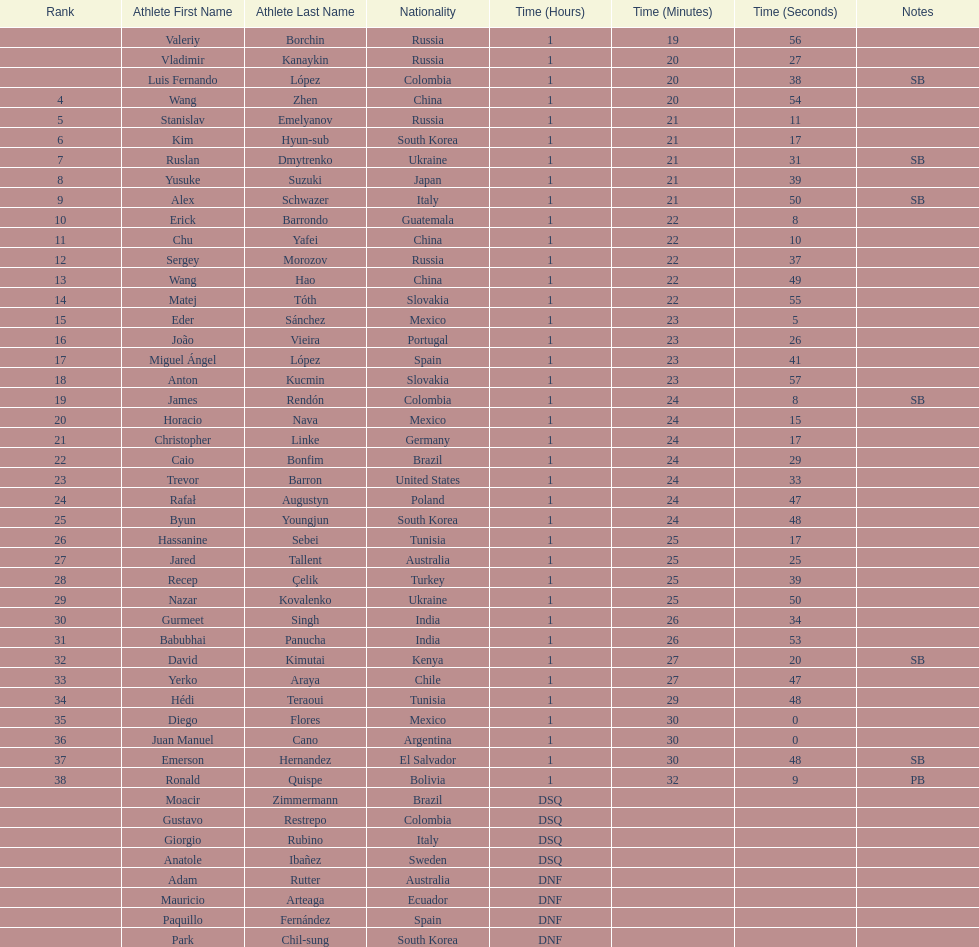Which athlete had the fastest time for the 20km? Valeriy Borchin. Can you parse all the data within this table? {'header': ['Rank', 'Athlete First Name', 'Athlete Last Name', 'Nationality', 'Time (Hours)', 'Time (Minutes)', 'Time (Seconds)', 'Notes'], 'rows': [['', 'Valeriy', 'Borchin', 'Russia', '1', '19', '56', ''], ['', 'Vladimir', 'Kanaykin', 'Russia', '1', '20', '27', ''], ['', 'Luis Fernando', 'López', 'Colombia', '1', '20', '38', 'SB'], ['4', 'Wang', 'Zhen', 'China', '1', '20', '54', ''], ['5', 'Stanislav', 'Emelyanov', 'Russia', '1', '21', '11', ''], ['6', 'Kim', 'Hyun-sub', 'South Korea', '1', '21', '17', ''], ['7', 'Ruslan', 'Dmytrenko', 'Ukraine', '1', '21', '31', 'SB'], ['8', 'Yusuke', 'Suzuki', 'Japan', '1', '21', '39', ''], ['9', 'Alex', 'Schwazer', 'Italy', '1', '21', '50', 'SB'], ['10', 'Erick', 'Barrondo', 'Guatemala', '1', '22', '8', ''], ['11', 'Chu', 'Yafei', 'China', '1', '22', '10', ''], ['12', 'Sergey', 'Morozov', 'Russia', '1', '22', '37', ''], ['13', 'Wang', 'Hao', 'China', '1', '22', '49', ''], ['14', 'Matej', 'Tóth', 'Slovakia', '1', '22', '55', ''], ['15', 'Eder', 'Sánchez', 'Mexico', '1', '23', '5', ''], ['16', 'João', 'Vieira', 'Portugal', '1', '23', '26', ''], ['17', 'Miguel Ángel', 'López', 'Spain', '1', '23', '41', ''], ['18', 'Anton', 'Kucmin', 'Slovakia', '1', '23', '57', ''], ['19', 'James', 'Rendón', 'Colombia', '1', '24', '8', 'SB'], ['20', 'Horacio', 'Nava', 'Mexico', '1', '24', '15', ''], ['21', 'Christopher', 'Linke', 'Germany', '1', '24', '17', ''], ['22', 'Caio', 'Bonfim', 'Brazil', '1', '24', '29', ''], ['23', 'Trevor', 'Barron', 'United States', '1', '24', '33', ''], ['24', 'Rafał', 'Augustyn', 'Poland', '1', '24', '47', ''], ['25', 'Byun', 'Youngjun', 'South Korea', '1', '24', '48', ''], ['26', 'Hassanine', 'Sebei', 'Tunisia', '1', '25', '17', ''], ['27', 'Jared', 'Tallent', 'Australia', '1', '25', '25', ''], ['28', 'Recep', 'Çelik', 'Turkey', '1', '25', '39', ''], ['29', 'Nazar', 'Kovalenko', 'Ukraine', '1', '25', '50', ''], ['30', 'Gurmeet', 'Singh', 'India', '1', '26', '34', ''], ['31', 'Babubhai', 'Panucha', 'India', '1', '26', '53', ''], ['32', 'David', 'Kimutai', 'Kenya', '1', '27', '20', 'SB'], ['33', 'Yerko', 'Araya', 'Chile', '1', '27', '47', ''], ['34', 'Hédi', 'Teraoui', 'Tunisia', '1', '29', '48', ''], ['35', 'Diego', 'Flores', 'Mexico', '1', '30', '0', ''], ['36', 'Juan Manuel', 'Cano', 'Argentina', '1', '30', '0', ''], ['37', 'Emerson', 'Hernandez', 'El Salvador', '1', '30', '48', 'SB'], ['38', 'Ronald', 'Quispe', 'Bolivia', '1', '32', '9', 'PB'], ['', 'Moacir', 'Zimmermann', 'Brazil', 'DSQ', '', '', ''], ['', 'Gustavo', 'Restrepo', 'Colombia', 'DSQ', '', '', ''], ['', 'Giorgio', 'Rubino', 'Italy', 'DSQ', '', '', ''], ['', 'Anatole', 'Ibañez', 'Sweden', 'DSQ', '', '', ''], ['', 'Adam', 'Rutter', 'Australia', 'DNF', '', '', ''], ['', 'Mauricio', 'Arteaga', 'Ecuador', 'DNF', '', '', ''], ['', 'Paquillo', 'Fernández', 'Spain', 'DNF', '', '', ''], ['', 'Park', 'Chil-sung', 'South Korea', 'DNF', '', '', '']]} 